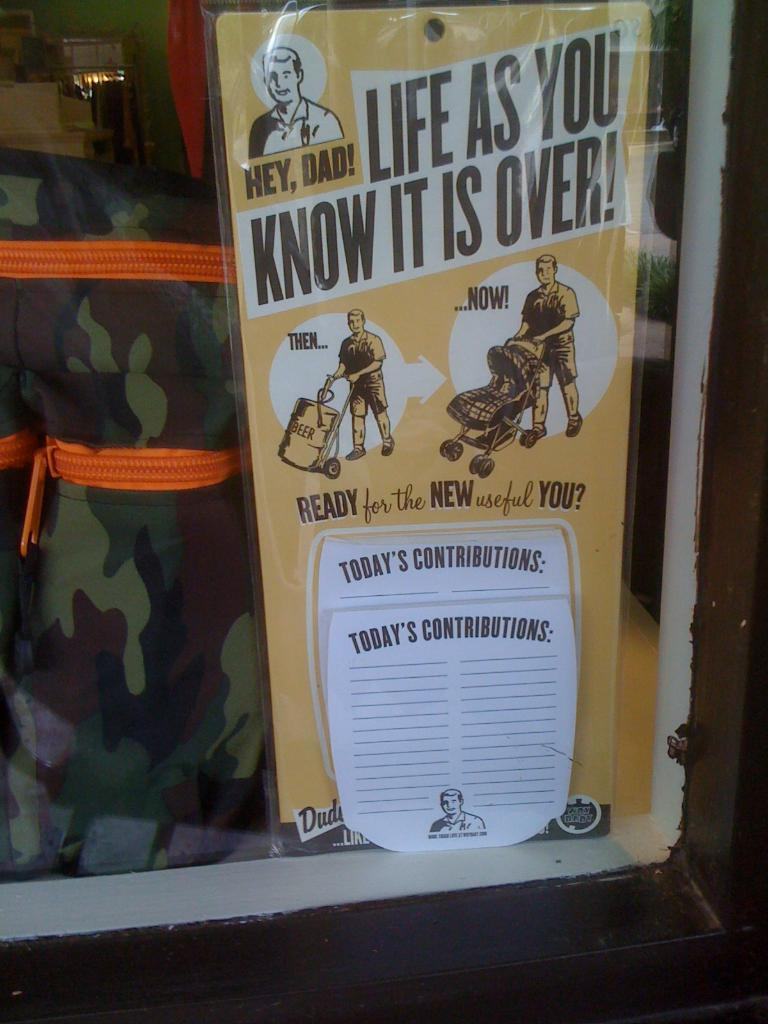<image>
Create a compact narrative representing the image presented. An advertisement shows a man pushing a beer keg with the label then and another with the man pushing a baby stroller and the label now. 